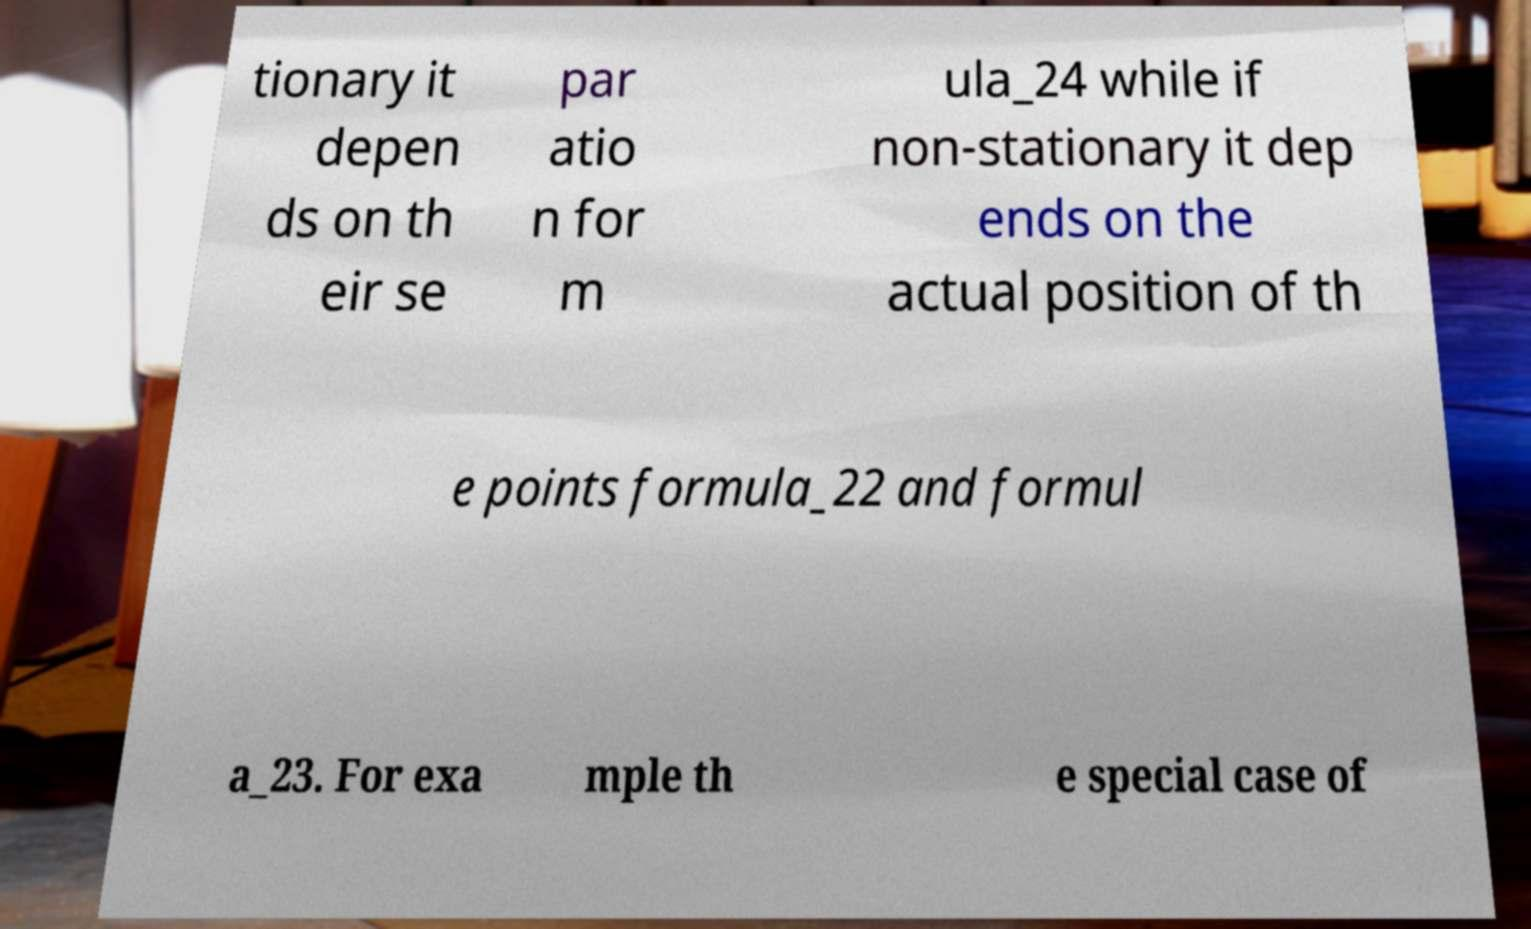Could you assist in decoding the text presented in this image and type it out clearly? tionary it depen ds on th eir se par atio n for m ula_24 while if non-stationary it dep ends on the actual position of th e points formula_22 and formul a_23. For exa mple th e special case of 